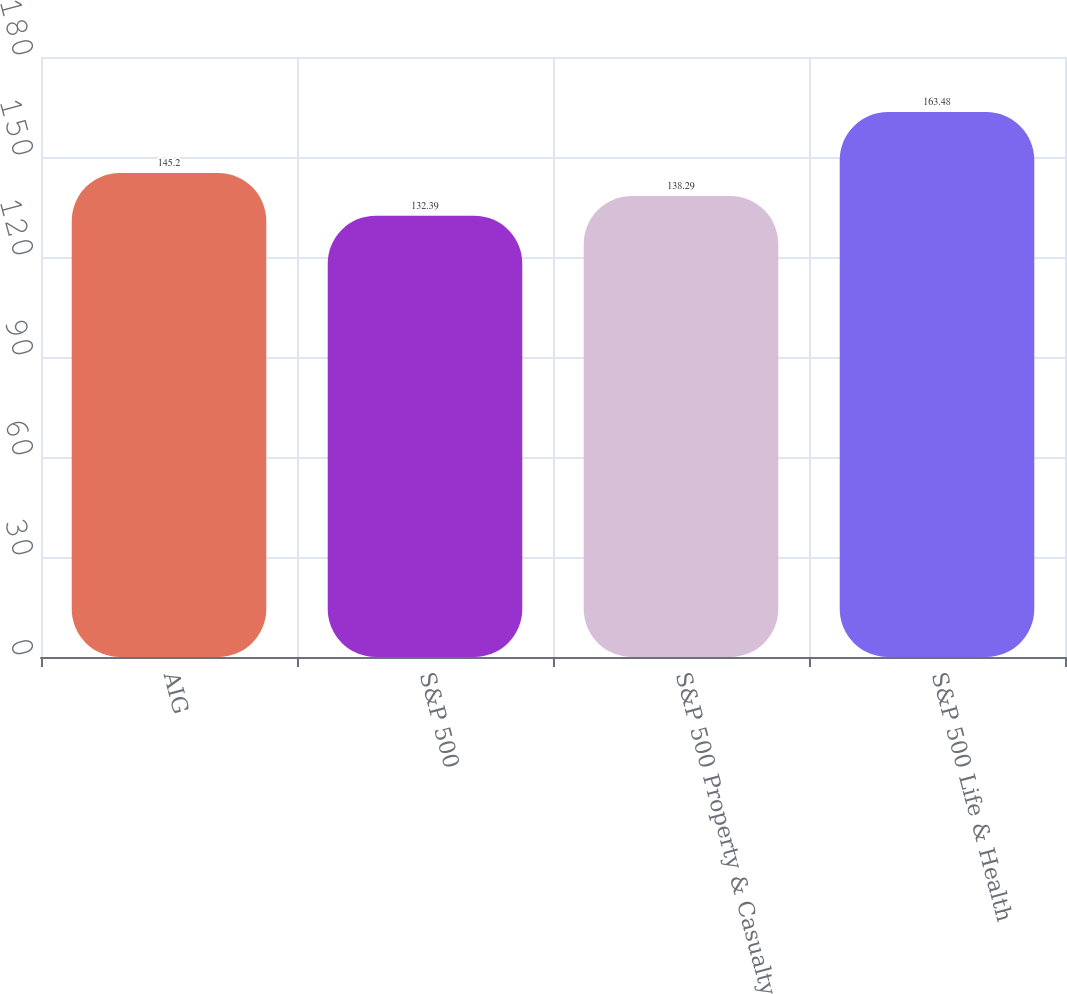Convert chart to OTSL. <chart><loc_0><loc_0><loc_500><loc_500><bar_chart><fcel>AIG<fcel>S&P 500<fcel>S&P 500 Property & Casualty<fcel>S&P 500 Life & Health<nl><fcel>145.2<fcel>132.39<fcel>138.29<fcel>163.48<nl></chart> 